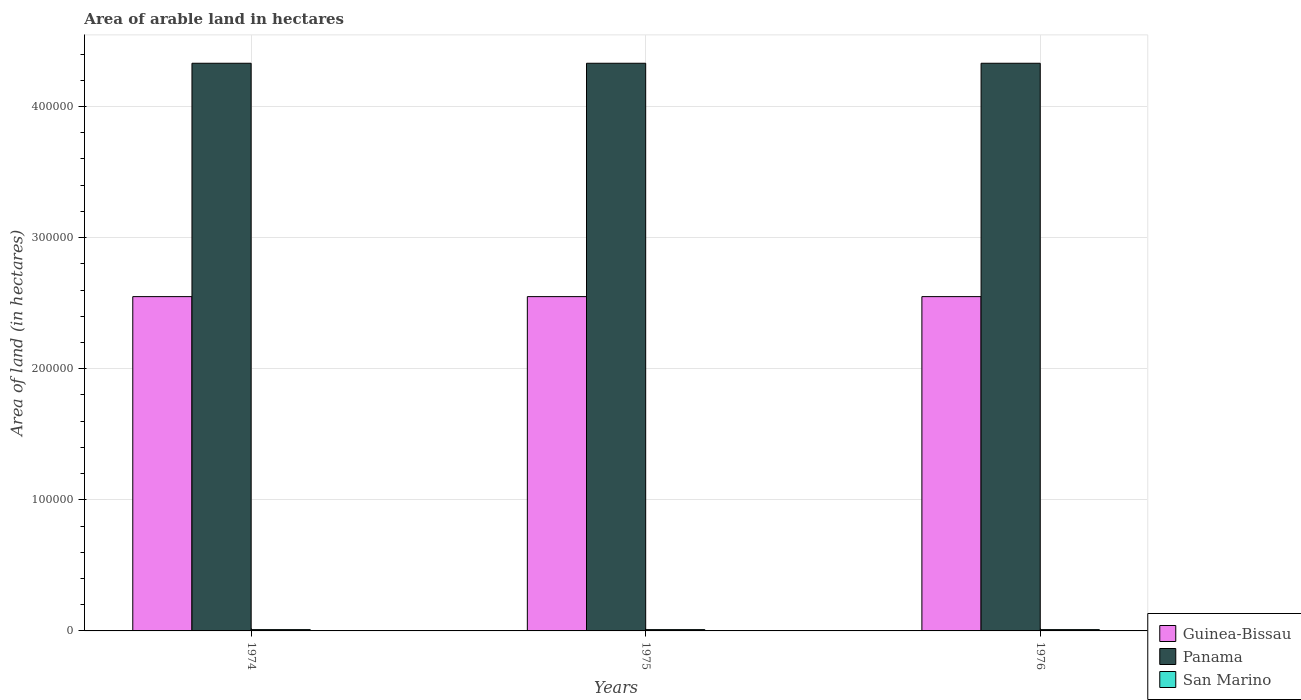Are the number of bars per tick equal to the number of legend labels?
Keep it short and to the point. Yes. Are the number of bars on each tick of the X-axis equal?
Ensure brevity in your answer.  Yes. How many bars are there on the 3rd tick from the left?
Your answer should be very brief. 3. What is the label of the 1st group of bars from the left?
Offer a terse response. 1974. What is the total arable land in San Marino in 1974?
Keep it short and to the point. 1000. Across all years, what is the maximum total arable land in Guinea-Bissau?
Provide a succinct answer. 2.55e+05. Across all years, what is the minimum total arable land in San Marino?
Provide a short and direct response. 1000. In which year was the total arable land in San Marino maximum?
Give a very brief answer. 1974. In which year was the total arable land in Panama minimum?
Your response must be concise. 1974. What is the total total arable land in Panama in the graph?
Offer a very short reply. 1.30e+06. What is the difference between the total arable land in San Marino in 1975 and the total arable land in Panama in 1976?
Make the answer very short. -4.32e+05. What is the average total arable land in San Marino per year?
Offer a terse response. 1000. In the year 1975, what is the difference between the total arable land in San Marino and total arable land in Guinea-Bissau?
Make the answer very short. -2.54e+05. Is the total arable land in Panama in 1975 less than that in 1976?
Provide a short and direct response. No. Is the difference between the total arable land in San Marino in 1974 and 1976 greater than the difference between the total arable land in Guinea-Bissau in 1974 and 1976?
Give a very brief answer. No. What does the 2nd bar from the left in 1974 represents?
Give a very brief answer. Panama. What does the 3rd bar from the right in 1976 represents?
Your answer should be very brief. Guinea-Bissau. Is it the case that in every year, the sum of the total arable land in Guinea-Bissau and total arable land in Panama is greater than the total arable land in San Marino?
Offer a very short reply. Yes. Are the values on the major ticks of Y-axis written in scientific E-notation?
Your response must be concise. No. Does the graph contain any zero values?
Ensure brevity in your answer.  No. Does the graph contain grids?
Keep it short and to the point. Yes. Where does the legend appear in the graph?
Give a very brief answer. Bottom right. What is the title of the graph?
Give a very brief answer. Area of arable land in hectares. Does "High income: nonOECD" appear as one of the legend labels in the graph?
Keep it short and to the point. No. What is the label or title of the Y-axis?
Offer a very short reply. Area of land (in hectares). What is the Area of land (in hectares) of Guinea-Bissau in 1974?
Provide a succinct answer. 2.55e+05. What is the Area of land (in hectares) of Panama in 1974?
Your answer should be very brief. 4.33e+05. What is the Area of land (in hectares) of San Marino in 1974?
Offer a terse response. 1000. What is the Area of land (in hectares) of Guinea-Bissau in 1975?
Give a very brief answer. 2.55e+05. What is the Area of land (in hectares) in Panama in 1975?
Give a very brief answer. 4.33e+05. What is the Area of land (in hectares) of San Marino in 1975?
Give a very brief answer. 1000. What is the Area of land (in hectares) in Guinea-Bissau in 1976?
Provide a short and direct response. 2.55e+05. What is the Area of land (in hectares) in Panama in 1976?
Your response must be concise. 4.33e+05. Across all years, what is the maximum Area of land (in hectares) in Guinea-Bissau?
Ensure brevity in your answer.  2.55e+05. Across all years, what is the maximum Area of land (in hectares) in Panama?
Your answer should be very brief. 4.33e+05. Across all years, what is the minimum Area of land (in hectares) of Guinea-Bissau?
Give a very brief answer. 2.55e+05. Across all years, what is the minimum Area of land (in hectares) of Panama?
Offer a very short reply. 4.33e+05. What is the total Area of land (in hectares) of Guinea-Bissau in the graph?
Give a very brief answer. 7.65e+05. What is the total Area of land (in hectares) of Panama in the graph?
Your response must be concise. 1.30e+06. What is the total Area of land (in hectares) in San Marino in the graph?
Provide a succinct answer. 3000. What is the difference between the Area of land (in hectares) in San Marino in 1974 and that in 1975?
Provide a short and direct response. 0. What is the difference between the Area of land (in hectares) in Panama in 1974 and that in 1976?
Your response must be concise. 0. What is the difference between the Area of land (in hectares) of Panama in 1975 and that in 1976?
Offer a terse response. 0. What is the difference between the Area of land (in hectares) in San Marino in 1975 and that in 1976?
Ensure brevity in your answer.  0. What is the difference between the Area of land (in hectares) of Guinea-Bissau in 1974 and the Area of land (in hectares) of Panama in 1975?
Your response must be concise. -1.78e+05. What is the difference between the Area of land (in hectares) in Guinea-Bissau in 1974 and the Area of land (in hectares) in San Marino in 1975?
Offer a terse response. 2.54e+05. What is the difference between the Area of land (in hectares) in Panama in 1974 and the Area of land (in hectares) in San Marino in 1975?
Your answer should be very brief. 4.32e+05. What is the difference between the Area of land (in hectares) of Guinea-Bissau in 1974 and the Area of land (in hectares) of Panama in 1976?
Offer a very short reply. -1.78e+05. What is the difference between the Area of land (in hectares) in Guinea-Bissau in 1974 and the Area of land (in hectares) in San Marino in 1976?
Give a very brief answer. 2.54e+05. What is the difference between the Area of land (in hectares) in Panama in 1974 and the Area of land (in hectares) in San Marino in 1976?
Your answer should be compact. 4.32e+05. What is the difference between the Area of land (in hectares) in Guinea-Bissau in 1975 and the Area of land (in hectares) in Panama in 1976?
Offer a terse response. -1.78e+05. What is the difference between the Area of land (in hectares) in Guinea-Bissau in 1975 and the Area of land (in hectares) in San Marino in 1976?
Ensure brevity in your answer.  2.54e+05. What is the difference between the Area of land (in hectares) in Panama in 1975 and the Area of land (in hectares) in San Marino in 1976?
Your answer should be compact. 4.32e+05. What is the average Area of land (in hectares) in Guinea-Bissau per year?
Offer a very short reply. 2.55e+05. What is the average Area of land (in hectares) of Panama per year?
Provide a short and direct response. 4.33e+05. What is the average Area of land (in hectares) in San Marino per year?
Offer a very short reply. 1000. In the year 1974, what is the difference between the Area of land (in hectares) in Guinea-Bissau and Area of land (in hectares) in Panama?
Offer a very short reply. -1.78e+05. In the year 1974, what is the difference between the Area of land (in hectares) in Guinea-Bissau and Area of land (in hectares) in San Marino?
Give a very brief answer. 2.54e+05. In the year 1974, what is the difference between the Area of land (in hectares) in Panama and Area of land (in hectares) in San Marino?
Offer a terse response. 4.32e+05. In the year 1975, what is the difference between the Area of land (in hectares) in Guinea-Bissau and Area of land (in hectares) in Panama?
Offer a terse response. -1.78e+05. In the year 1975, what is the difference between the Area of land (in hectares) of Guinea-Bissau and Area of land (in hectares) of San Marino?
Offer a very short reply. 2.54e+05. In the year 1975, what is the difference between the Area of land (in hectares) of Panama and Area of land (in hectares) of San Marino?
Ensure brevity in your answer.  4.32e+05. In the year 1976, what is the difference between the Area of land (in hectares) of Guinea-Bissau and Area of land (in hectares) of Panama?
Your response must be concise. -1.78e+05. In the year 1976, what is the difference between the Area of land (in hectares) in Guinea-Bissau and Area of land (in hectares) in San Marino?
Give a very brief answer. 2.54e+05. In the year 1976, what is the difference between the Area of land (in hectares) in Panama and Area of land (in hectares) in San Marino?
Provide a succinct answer. 4.32e+05. What is the ratio of the Area of land (in hectares) in Guinea-Bissau in 1974 to that in 1975?
Provide a short and direct response. 1. What is the ratio of the Area of land (in hectares) of San Marino in 1974 to that in 1975?
Make the answer very short. 1. What is the ratio of the Area of land (in hectares) of San Marino in 1975 to that in 1976?
Ensure brevity in your answer.  1. What is the difference between the highest and the second highest Area of land (in hectares) of Guinea-Bissau?
Your answer should be compact. 0. What is the difference between the highest and the second highest Area of land (in hectares) of San Marino?
Offer a terse response. 0. What is the difference between the highest and the lowest Area of land (in hectares) of Panama?
Provide a succinct answer. 0. 